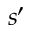Convert formula to latex. <formula><loc_0><loc_0><loc_500><loc_500>s { ^ { \prime } }</formula> 